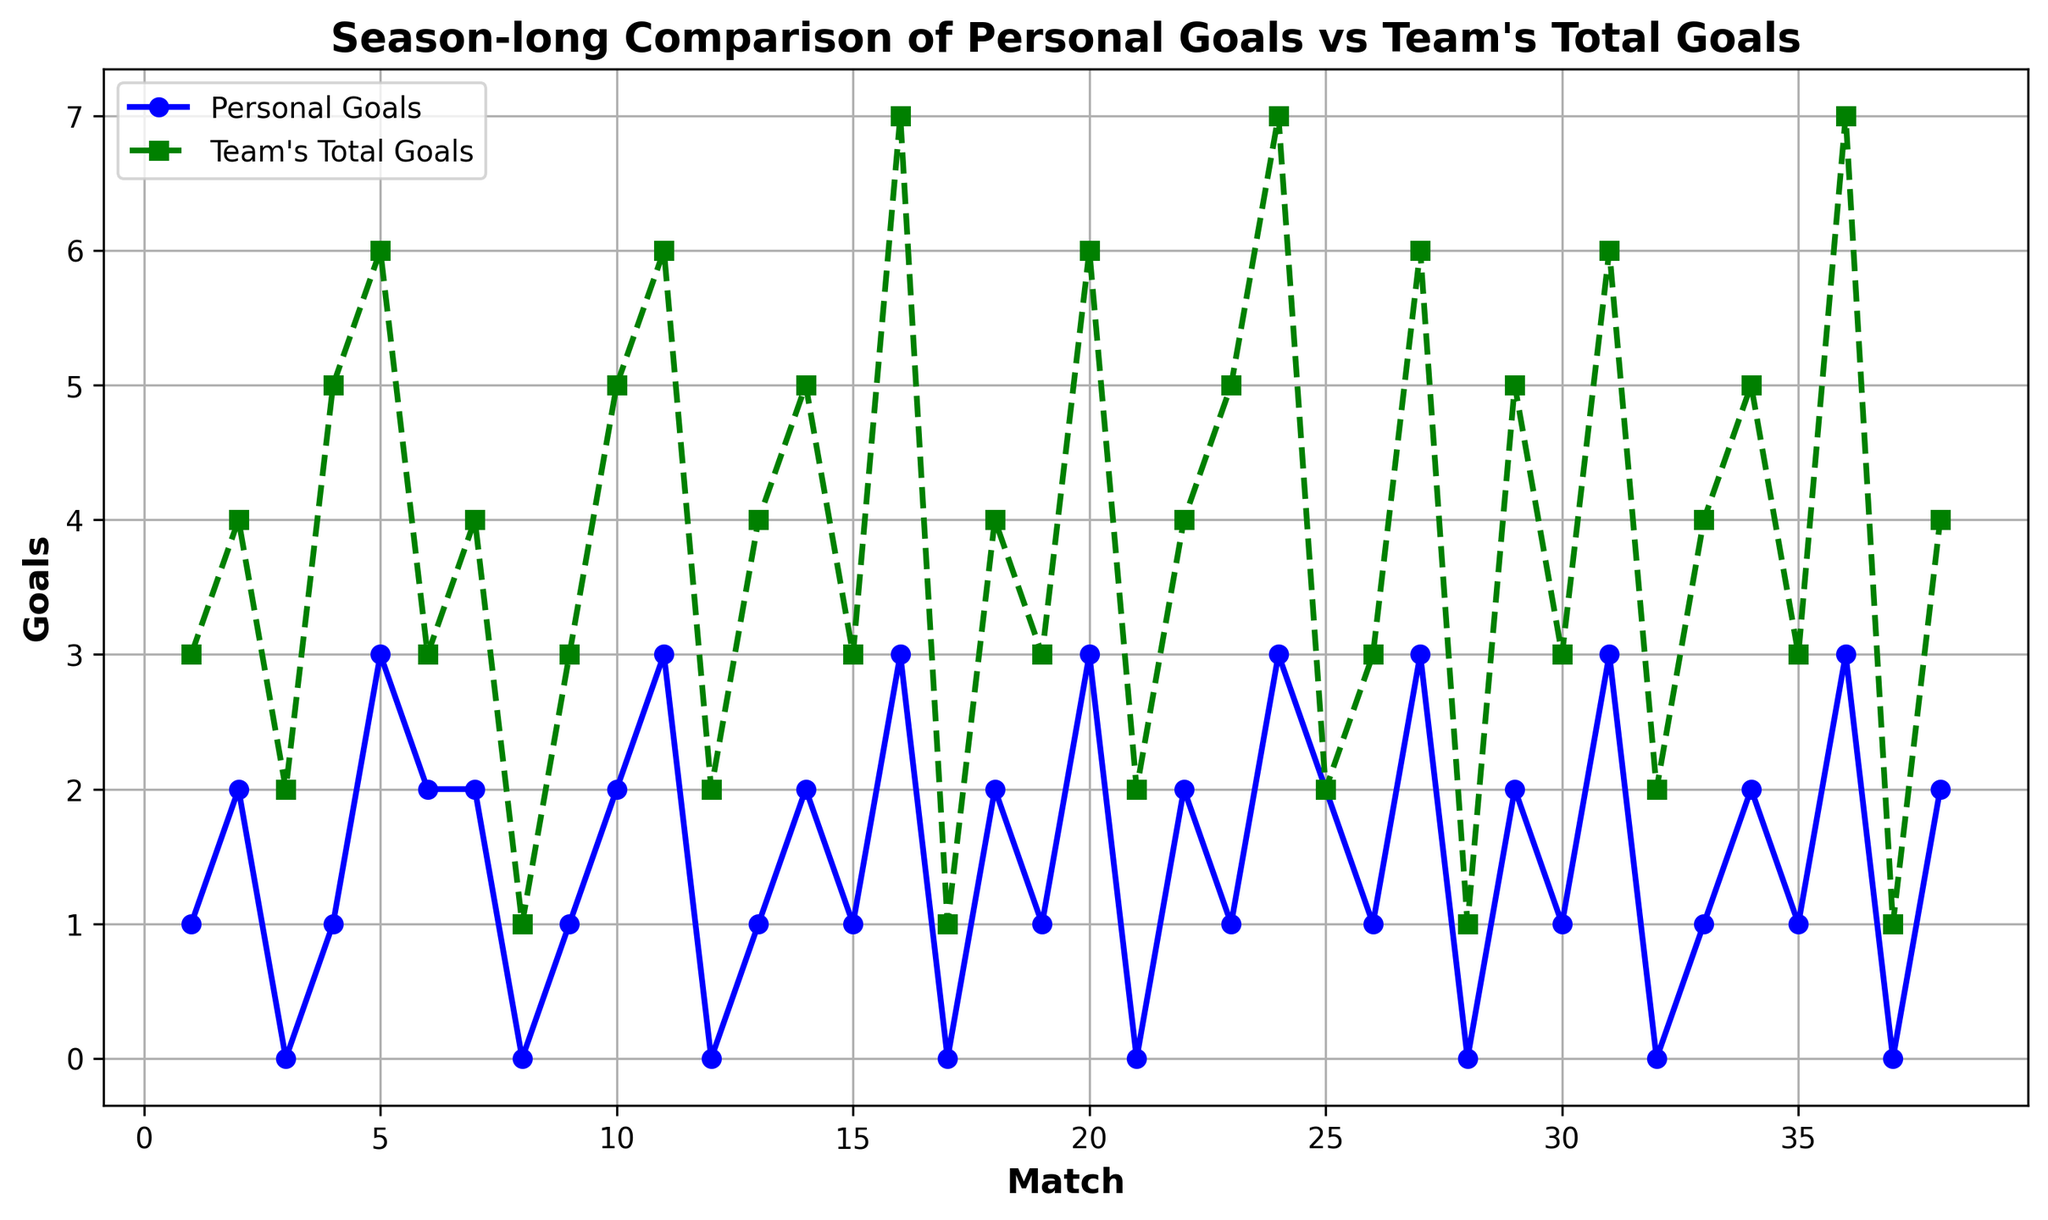What's the total number of personal goals in matches 1 to 10? Sum the personal goals for matches 1 to 10: 1+2+0+1+3+2+2+0+1+2 = 14
Answer: 14 Which match had the highest team's total goals and what was that value? The highest team's total goals can be seen at match 16 and match 36, both showing a value of 7
Answer: 16 and 36, 7 In which matches did the personal goals and team's total goals both equal zero? Look for matches where both series touch the x-axis. There are no matches where both equal zero.
Answer: None On average, how many goals did you score per match over the season? Sum the personal goals for all 38 matches, then divide by 38: (sum of personal goals) / 38 = (48) / 38 ≈ 1.26
Answer: 1.26 Which match had the largest difference between the team's total goals and personal goals? Compare the differences for each match: match 16 had a difference of 4 goals; team's total was 7 and personal goals were 3.
Answer: Match 16 In which match did your personal goals equal the team's total goals? Find matches where both lines intersect at the same point: match 25, both equal 2.
Answer: Match 25 When you scored zero personal goals, what was the highest team's total goals? Identify matches where personal goals line is at 0 and find the highest point on the team's total goals line in those matches. The highest team's total goals when you scored zero was in match 12 with 2 goals.
Answer: Match 12, 2 In which match did you score three goals and how did the team perform in that match? Look for an intersection in the personal goals line at 3. Match 5, 11, 16, 20, 27, 31, and 36 had three personal goals. The highest team's total goals of 7 occurred in matches 16 and 36.
Answer: Matches 16 and 36, 7 goals each Considering matches 1 to 19, what is the difference between the total personal goals and team's total goals? Sum personal and team's goals separately for matches 1 to 19: (1+2+0+1+3+2+2+0+1+2+3+0+1+2+1+3+0+2+1) = 29 for personal, and (3+4+2+5+6+3+4+1+3+5+6+2+4+5+3+7+1+4+3) = 70 for team. Difference: 70 - 29 = 41
Answer: 41 In which match did the team's total goals see the sharpest drop compared to the previous match, and what was the decrease? Compare the differences between consecutive matches: from match 16 to 17, there is a drop from 7 to 1. The decrease is 6.
Answer: Match 17, decrease of 6 